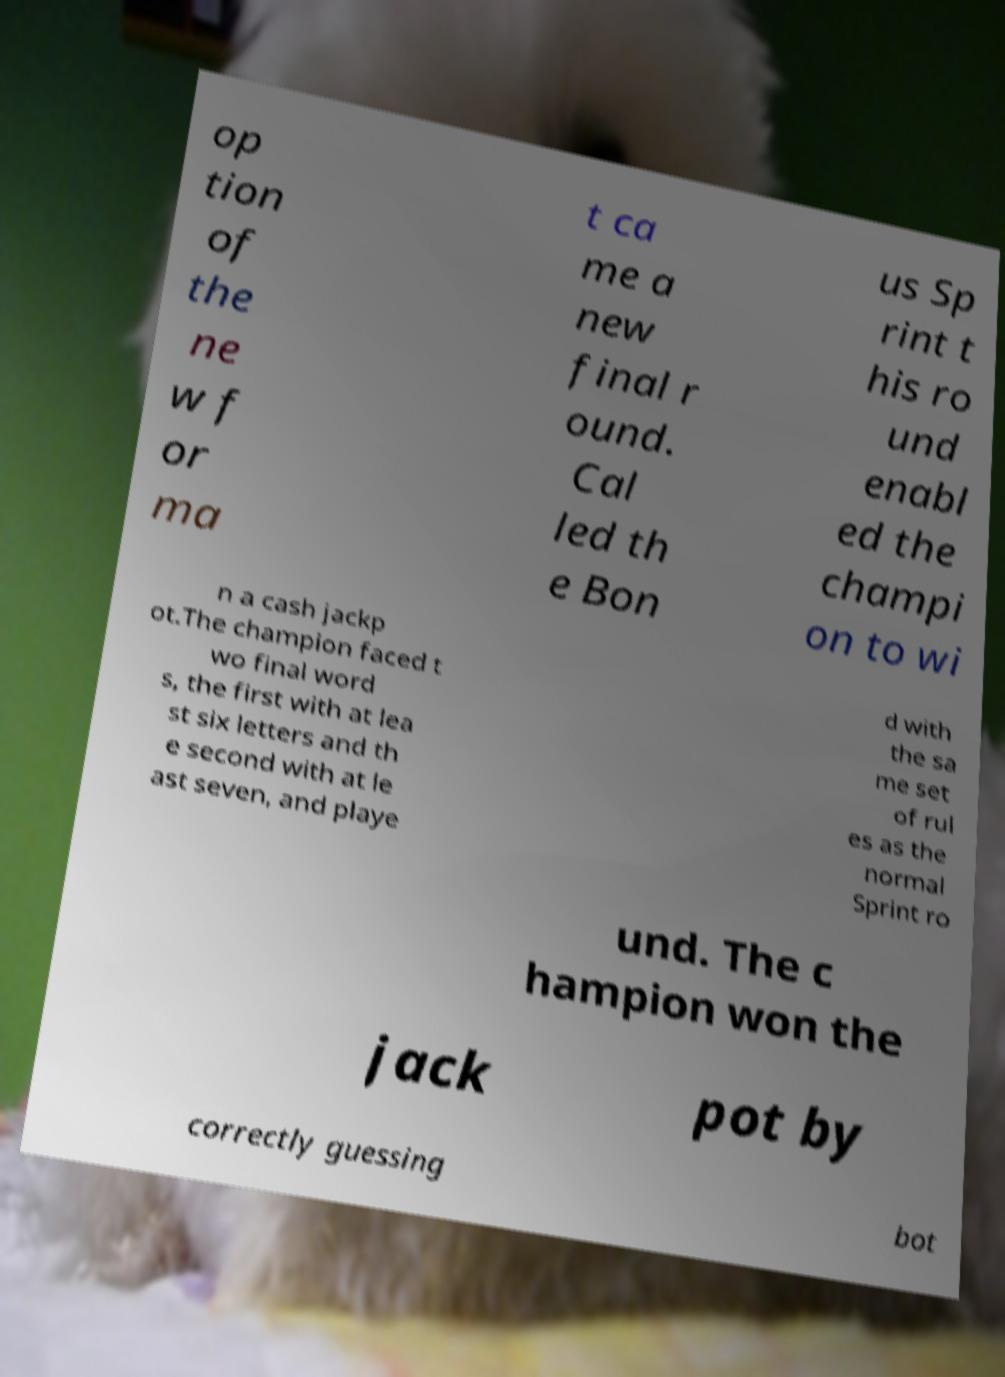Can you accurately transcribe the text from the provided image for me? op tion of the ne w f or ma t ca me a new final r ound. Cal led th e Bon us Sp rint t his ro und enabl ed the champi on to wi n a cash jackp ot.The champion faced t wo final word s, the first with at lea st six letters and th e second with at le ast seven, and playe d with the sa me set of rul es as the normal Sprint ro und. The c hampion won the jack pot by correctly guessing bot 